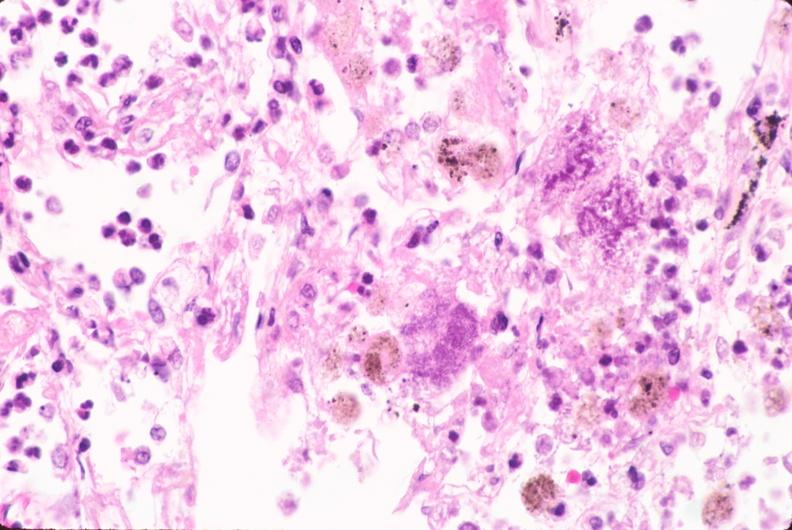s respiratory present?
Answer the question using a single word or phrase. Yes 